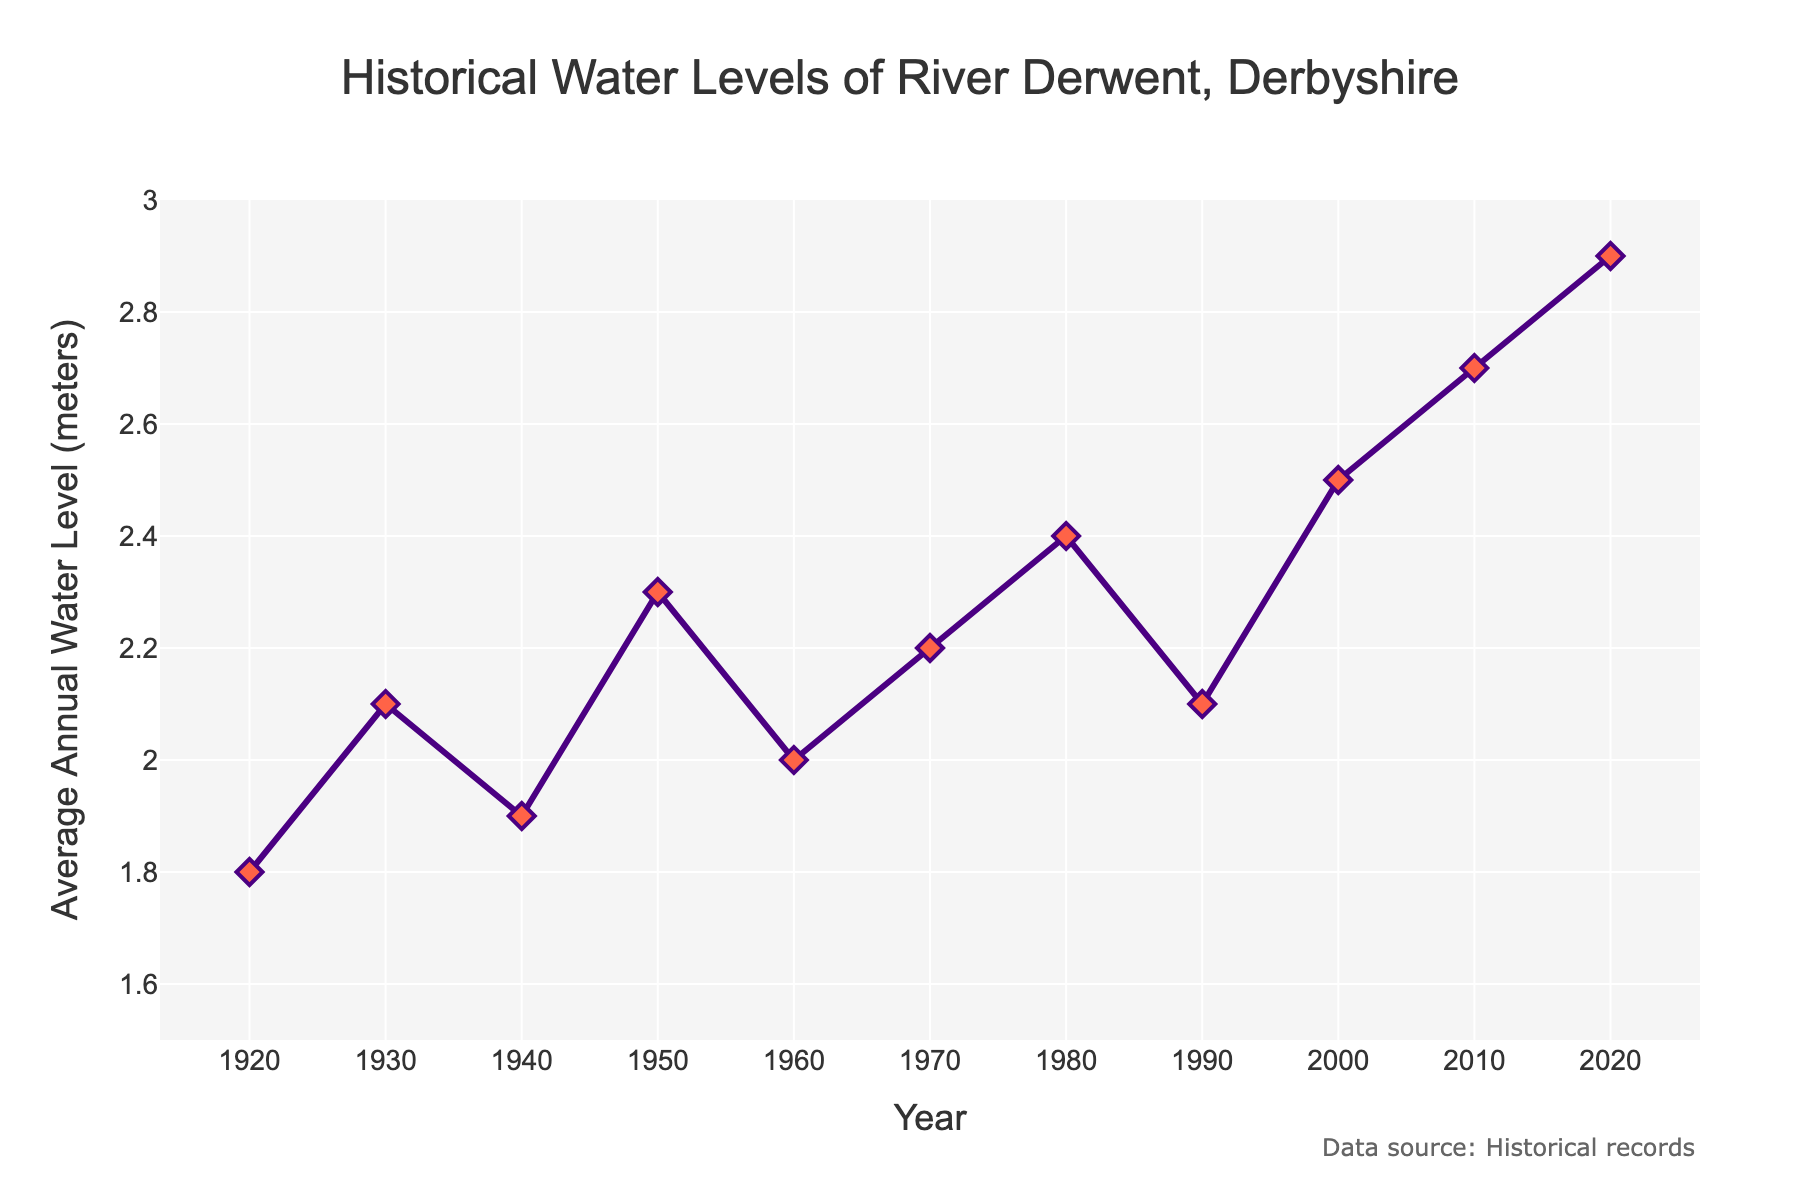What's the highest water level recorded in the past century? To find the highest water level, we look for the tallest point on the line chart. The highest average annual water level recorded is in 2020 at 2.9 meters.
Answer: 2.9 meters Which decade saw the most significant decrease in water levels? We need to identify the decade with the steepest decline on the line chart. From 1950 to 1960, the water level dropped from 2.3 meters to 2.0 meters, a 0.3 meters decrease, which is the most significant decrease.
Answer: 1950-1960 How does the water level in 1980 compare to that in 2020? Comparing the points for the years 1980 and 2020 on the line chart, we see that the water level in 1980 was 2.4 meters, whereas in 2020 it was 2.9 meters. Thus, the water level in 2020 is 0.5 meters higher than in 1980.
Answer: 0.5 meters higher What is the average water level for the years 1960, 1970, and 1980? To find the average, we add the water levels for 1960 (2.0 meters), 1970 (2.2 meters), and 1980 (2.4 meters) and then divide by 3. The average is (2.0 + 2.2 + 2.4) / 3 = 2.2 meters.
Answer: 2.2 meters Which period has a more stable water level, 1920-1940 or 2000-2020? To determine stability, we observe the fluctuations in the lines for each period. The period 1920-1940 shows less variation, with water levels ranging from 1.8 to 2.1 meters, while 2000-2020 ranges from 2.5 to 2.9 meters. Thus, 1920-1940 is more stable.
Answer: 1920-1940 What is the range of water levels recorded in the decade from 1990 to 2000? The range is calculated by subtracting the lowest value from the highest value within the specified decade. For 1990-2000, the water levels are 2.1 meters in 1990 and 2.5 meters in 2000. Therefore, the range is 2.5 - 2.1 = 0.4 meters.
Answer: 0.4 meters Between which consecutive decades did the water level first increase by more than 0.3 meters? We compare the changes between each consecutive decade. The water level increased from 2.3 meters in 1950 to 2.0 meters in 1960 (a decrease), 2.0 meters in 1960 to 2.2 meters in 1970 (0.2 meters increase), 2.2 meters in 1970 to 2.4 meters in 1980 (0.2 meters increase), 2.4 meters in 1980 to 2.1 meters in 1990 (a decrease), 2.1 meters in 1990 to 2.5 meters in 2000 (0.4 meters increase). Therefore, the first increase of more than 0.3 meters is between 1990 and 2000.
Answer: 1990-2000 What was the water level in 1950? We simply look at the data point for the year 1950. The water level in 1950 was 2.3 meters.
Answer: 2.3 meters 